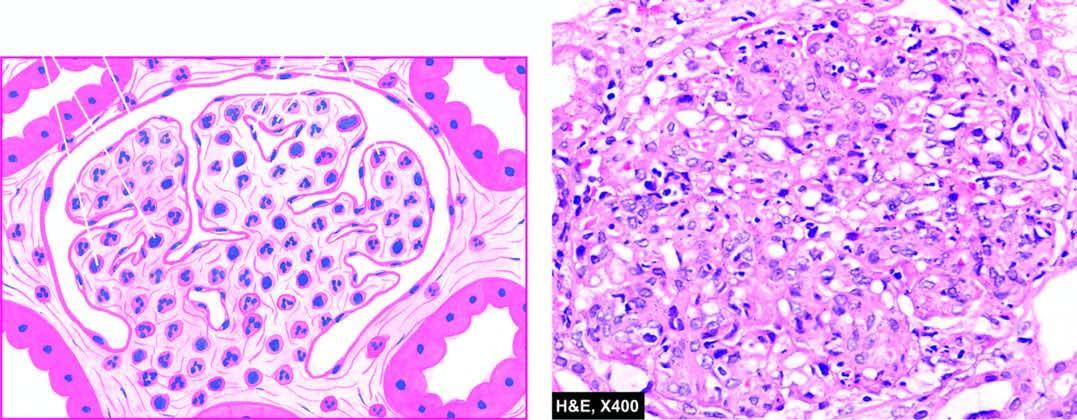what is there increased due to proliferation of mesangial cels, endothelial cells and some epithelial cells and infiltration of the tuft by neutrophils and monocytes?
Answer the question using a single word or phrase. Increased cellularity 